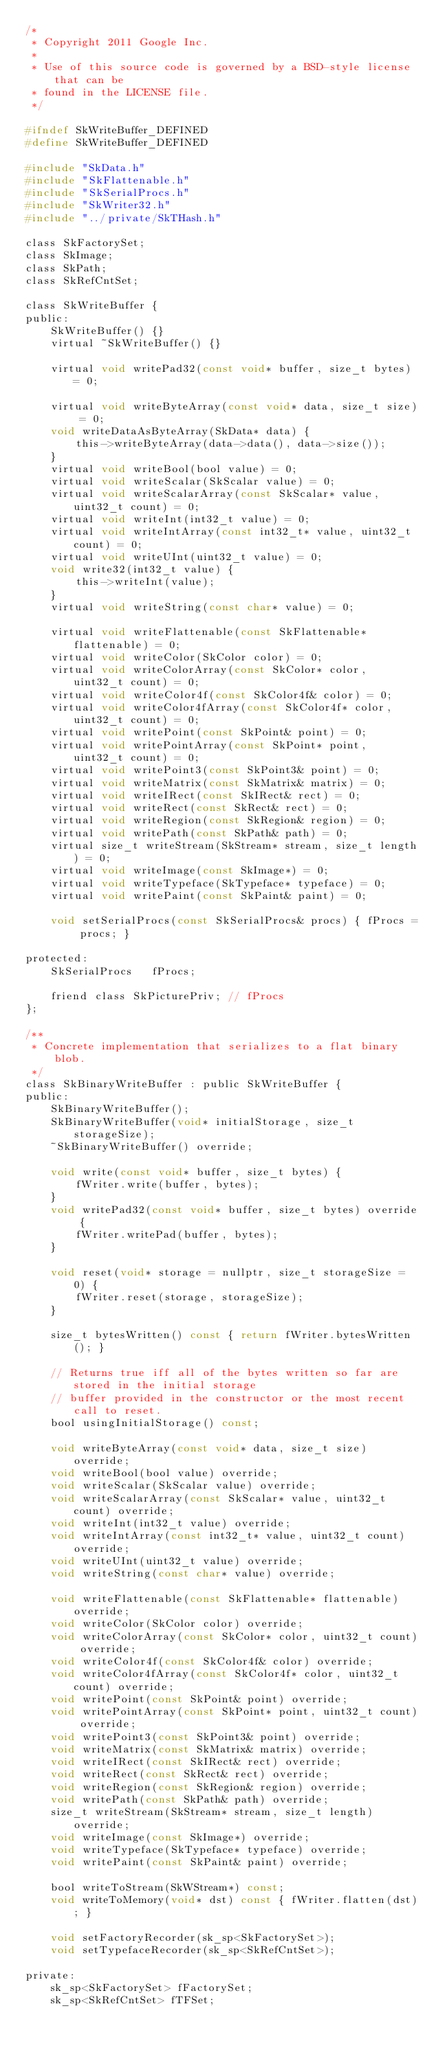<code> <loc_0><loc_0><loc_500><loc_500><_C_>/*
 * Copyright 2011 Google Inc.
 *
 * Use of this source code is governed by a BSD-style license that can be
 * found in the LICENSE file.
 */

#ifndef SkWriteBuffer_DEFINED
#define SkWriteBuffer_DEFINED

#include "SkData.h"
#include "SkFlattenable.h"
#include "SkSerialProcs.h"
#include "SkWriter32.h"
#include "../private/SkTHash.h"

class SkFactorySet;
class SkImage;
class SkPath;
class SkRefCntSet;

class SkWriteBuffer {
public:
    SkWriteBuffer() {}
    virtual ~SkWriteBuffer() {}

    virtual void writePad32(const void* buffer, size_t bytes) = 0;

    virtual void writeByteArray(const void* data, size_t size) = 0;
    void writeDataAsByteArray(SkData* data) {
        this->writeByteArray(data->data(), data->size());
    }
    virtual void writeBool(bool value) = 0;
    virtual void writeScalar(SkScalar value) = 0;
    virtual void writeScalarArray(const SkScalar* value, uint32_t count) = 0;
    virtual void writeInt(int32_t value) = 0;
    virtual void writeIntArray(const int32_t* value, uint32_t count) = 0;
    virtual void writeUInt(uint32_t value) = 0;
    void write32(int32_t value) {
        this->writeInt(value);
    }
    virtual void writeString(const char* value) = 0;

    virtual void writeFlattenable(const SkFlattenable* flattenable) = 0;
    virtual void writeColor(SkColor color) = 0;
    virtual void writeColorArray(const SkColor* color, uint32_t count) = 0;
    virtual void writeColor4f(const SkColor4f& color) = 0;
    virtual void writeColor4fArray(const SkColor4f* color, uint32_t count) = 0;
    virtual void writePoint(const SkPoint& point) = 0;
    virtual void writePointArray(const SkPoint* point, uint32_t count) = 0;
    virtual void writePoint3(const SkPoint3& point) = 0;
    virtual void writeMatrix(const SkMatrix& matrix) = 0;
    virtual void writeIRect(const SkIRect& rect) = 0;
    virtual void writeRect(const SkRect& rect) = 0;
    virtual void writeRegion(const SkRegion& region) = 0;
    virtual void writePath(const SkPath& path) = 0;
    virtual size_t writeStream(SkStream* stream, size_t length) = 0;
    virtual void writeImage(const SkImage*) = 0;
    virtual void writeTypeface(SkTypeface* typeface) = 0;
    virtual void writePaint(const SkPaint& paint) = 0;

    void setSerialProcs(const SkSerialProcs& procs) { fProcs = procs; }

protected:
    SkSerialProcs   fProcs;

    friend class SkPicturePriv; // fProcs
};

/**
 * Concrete implementation that serializes to a flat binary blob.
 */
class SkBinaryWriteBuffer : public SkWriteBuffer {
public:
    SkBinaryWriteBuffer();
    SkBinaryWriteBuffer(void* initialStorage, size_t storageSize);
    ~SkBinaryWriteBuffer() override;

    void write(const void* buffer, size_t bytes) {
        fWriter.write(buffer, bytes);
    }
    void writePad32(const void* buffer, size_t bytes) override {
        fWriter.writePad(buffer, bytes);
    }

    void reset(void* storage = nullptr, size_t storageSize = 0) {
        fWriter.reset(storage, storageSize);
    }

    size_t bytesWritten() const { return fWriter.bytesWritten(); }

    // Returns true iff all of the bytes written so far are stored in the initial storage
    // buffer provided in the constructor or the most recent call to reset.
    bool usingInitialStorage() const;

    void writeByteArray(const void* data, size_t size) override;
    void writeBool(bool value) override;
    void writeScalar(SkScalar value) override;
    void writeScalarArray(const SkScalar* value, uint32_t count) override;
    void writeInt(int32_t value) override;
    void writeIntArray(const int32_t* value, uint32_t count) override;
    void writeUInt(uint32_t value) override;
    void writeString(const char* value) override;

    void writeFlattenable(const SkFlattenable* flattenable) override;
    void writeColor(SkColor color) override;
    void writeColorArray(const SkColor* color, uint32_t count) override;
    void writeColor4f(const SkColor4f& color) override;
    void writeColor4fArray(const SkColor4f* color, uint32_t count) override;
    void writePoint(const SkPoint& point) override;
    void writePointArray(const SkPoint* point, uint32_t count) override;
    void writePoint3(const SkPoint3& point) override;
    void writeMatrix(const SkMatrix& matrix) override;
    void writeIRect(const SkIRect& rect) override;
    void writeRect(const SkRect& rect) override;
    void writeRegion(const SkRegion& region) override;
    void writePath(const SkPath& path) override;
    size_t writeStream(SkStream* stream, size_t length) override;
    void writeImage(const SkImage*) override;
    void writeTypeface(SkTypeface* typeface) override;
    void writePaint(const SkPaint& paint) override;

    bool writeToStream(SkWStream*) const;
    void writeToMemory(void* dst) const { fWriter.flatten(dst); }

    void setFactoryRecorder(sk_sp<SkFactorySet>);
    void setTypefaceRecorder(sk_sp<SkRefCntSet>);

private:
    sk_sp<SkFactorySet> fFactorySet;
    sk_sp<SkRefCntSet> fTFSet;
</code> 